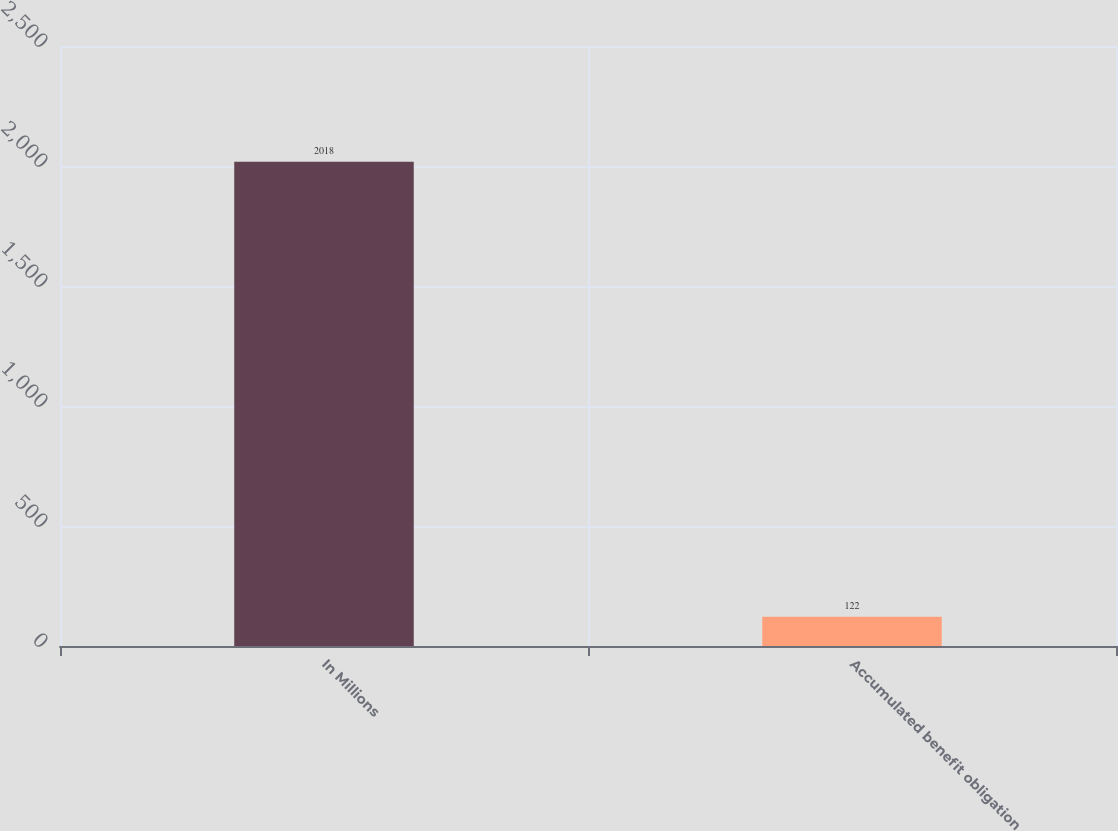Convert chart to OTSL. <chart><loc_0><loc_0><loc_500><loc_500><bar_chart><fcel>In Millions<fcel>Accumulated benefit obligation<nl><fcel>2018<fcel>122<nl></chart> 